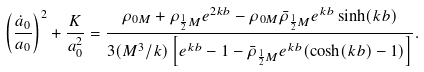Convert formula to latex. <formula><loc_0><loc_0><loc_500><loc_500>\left ( \frac { \dot { a } _ { 0 } } { a _ { 0 } } \right ) ^ { 2 } + \frac { K } { a _ { 0 } ^ { 2 } } = \frac { \rho _ { 0 M } + \rho _ { \frac { 1 } { 2 } M } e ^ { 2 k b } - \rho _ { 0 M } \bar { \rho } _ { \frac { 1 } { 2 } M } e ^ { k b } \sinh ( k b ) } { 3 ( M ^ { 3 } / k ) \left [ e ^ { k b } - 1 - \bar { \rho } _ { \frac { 1 } { 2 } M } e ^ { k b } ( \cosh ( k b ) - 1 ) \right ] } .</formula> 